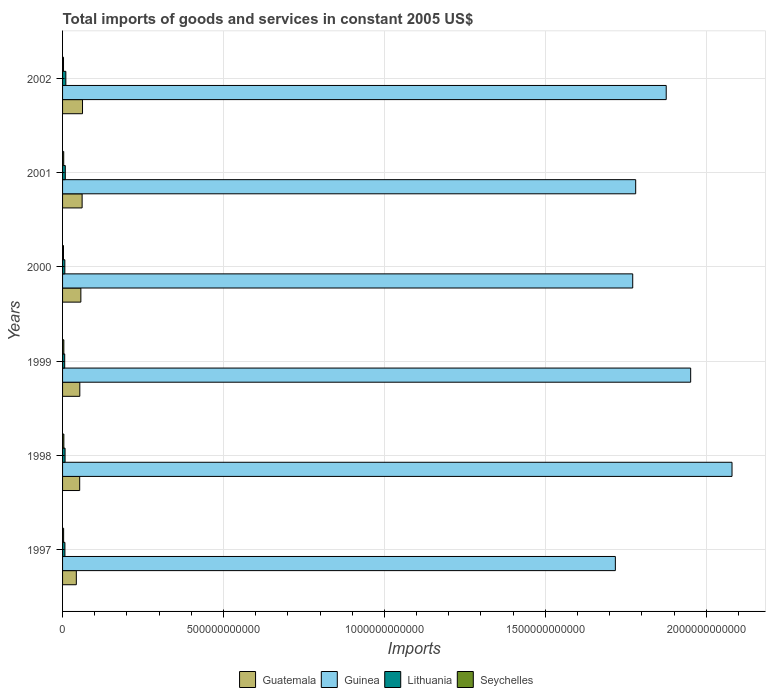How many different coloured bars are there?
Provide a succinct answer. 4. Are the number of bars on each tick of the Y-axis equal?
Ensure brevity in your answer.  Yes. How many bars are there on the 4th tick from the top?
Your answer should be very brief. 4. In how many cases, is the number of bars for a given year not equal to the number of legend labels?
Provide a succinct answer. 0. What is the total imports of goods and services in Guatemala in 2000?
Provide a short and direct response. 5.68e+1. Across all years, what is the maximum total imports of goods and services in Seychelles?
Your answer should be compact. 4.04e+09. Across all years, what is the minimum total imports of goods and services in Seychelles?
Your response must be concise. 2.89e+09. What is the total total imports of goods and services in Guinea in the graph?
Keep it short and to the point. 1.12e+13. What is the difference between the total imports of goods and services in Seychelles in 1998 and that in 2001?
Your response must be concise. 4.43e+08. What is the difference between the total imports of goods and services in Seychelles in 1998 and the total imports of goods and services in Guinea in 1999?
Ensure brevity in your answer.  -1.95e+12. What is the average total imports of goods and services in Lithuania per year?
Offer a terse response. 7.92e+09. In the year 1997, what is the difference between the total imports of goods and services in Guatemala and total imports of goods and services in Lithuania?
Ensure brevity in your answer.  3.54e+1. What is the ratio of the total imports of goods and services in Guinea in 1999 to that in 2000?
Your answer should be compact. 1.1. What is the difference between the highest and the second highest total imports of goods and services in Guatemala?
Provide a short and direct response. 1.21e+09. What is the difference between the highest and the lowest total imports of goods and services in Lithuania?
Your response must be concise. 3.54e+09. Is it the case that in every year, the sum of the total imports of goods and services in Guatemala and total imports of goods and services in Seychelles is greater than the sum of total imports of goods and services in Lithuania and total imports of goods and services in Guinea?
Provide a succinct answer. Yes. What does the 2nd bar from the top in 2000 represents?
Your answer should be very brief. Lithuania. What does the 4th bar from the bottom in 2000 represents?
Your answer should be compact. Seychelles. Is it the case that in every year, the sum of the total imports of goods and services in Seychelles and total imports of goods and services in Guinea is greater than the total imports of goods and services in Guatemala?
Your answer should be compact. Yes. What is the difference between two consecutive major ticks on the X-axis?
Your response must be concise. 5.00e+11. Does the graph contain any zero values?
Offer a terse response. No. Does the graph contain grids?
Give a very brief answer. Yes. Where does the legend appear in the graph?
Give a very brief answer. Bottom center. How are the legend labels stacked?
Make the answer very short. Horizontal. What is the title of the graph?
Keep it short and to the point. Total imports of goods and services in constant 2005 US$. What is the label or title of the X-axis?
Make the answer very short. Imports. What is the Imports in Guatemala in 1997?
Ensure brevity in your answer.  4.27e+1. What is the Imports of Guinea in 1997?
Offer a terse response. 1.72e+12. What is the Imports in Lithuania in 1997?
Your response must be concise. 7.31e+09. What is the Imports in Seychelles in 1997?
Make the answer very short. 3.27e+09. What is the Imports in Guatemala in 1998?
Offer a terse response. 5.32e+1. What is the Imports of Guinea in 1998?
Ensure brevity in your answer.  2.08e+12. What is the Imports in Lithuania in 1998?
Your answer should be compact. 7.78e+09. What is the Imports of Seychelles in 1998?
Keep it short and to the point. 4.04e+09. What is the Imports in Guatemala in 1999?
Offer a terse response. 5.36e+1. What is the Imports in Guinea in 1999?
Provide a succinct answer. 1.95e+12. What is the Imports of Lithuania in 1999?
Ensure brevity in your answer.  6.65e+09. What is the Imports of Seychelles in 1999?
Your answer should be very brief. 3.99e+09. What is the Imports in Guatemala in 2000?
Offer a terse response. 5.68e+1. What is the Imports in Guinea in 2000?
Provide a succinct answer. 1.77e+12. What is the Imports in Lithuania in 2000?
Make the answer very short. 7.09e+09. What is the Imports of Seychelles in 2000?
Keep it short and to the point. 2.89e+09. What is the Imports of Guatemala in 2001?
Your answer should be compact. 6.08e+1. What is the Imports of Guinea in 2001?
Offer a terse response. 1.78e+12. What is the Imports of Lithuania in 2001?
Your answer should be very brief. 8.48e+09. What is the Imports in Seychelles in 2001?
Offer a terse response. 3.60e+09. What is the Imports of Guatemala in 2002?
Your answer should be compact. 6.20e+1. What is the Imports of Guinea in 2002?
Ensure brevity in your answer.  1.88e+12. What is the Imports of Lithuania in 2002?
Make the answer very short. 1.02e+1. What is the Imports of Seychelles in 2002?
Your answer should be very brief. 2.96e+09. Across all years, what is the maximum Imports of Guatemala?
Offer a terse response. 6.20e+1. Across all years, what is the maximum Imports of Guinea?
Ensure brevity in your answer.  2.08e+12. Across all years, what is the maximum Imports in Lithuania?
Keep it short and to the point. 1.02e+1. Across all years, what is the maximum Imports of Seychelles?
Your answer should be very brief. 4.04e+09. Across all years, what is the minimum Imports of Guatemala?
Give a very brief answer. 4.27e+1. Across all years, what is the minimum Imports of Guinea?
Offer a very short reply. 1.72e+12. Across all years, what is the minimum Imports of Lithuania?
Give a very brief answer. 6.65e+09. Across all years, what is the minimum Imports in Seychelles?
Your response must be concise. 2.89e+09. What is the total Imports of Guatemala in the graph?
Give a very brief answer. 3.29e+11. What is the total Imports of Guinea in the graph?
Offer a terse response. 1.12e+13. What is the total Imports in Lithuania in the graph?
Ensure brevity in your answer.  4.75e+1. What is the total Imports of Seychelles in the graph?
Ensure brevity in your answer.  2.07e+1. What is the difference between the Imports in Guatemala in 1997 and that in 1998?
Offer a very short reply. -1.05e+1. What is the difference between the Imports of Guinea in 1997 and that in 1998?
Provide a short and direct response. -3.62e+11. What is the difference between the Imports in Lithuania in 1997 and that in 1998?
Keep it short and to the point. -4.70e+08. What is the difference between the Imports in Seychelles in 1997 and that in 1998?
Make the answer very short. -7.69e+08. What is the difference between the Imports in Guatemala in 1997 and that in 1999?
Offer a terse response. -1.09e+1. What is the difference between the Imports in Guinea in 1997 and that in 1999?
Give a very brief answer. -2.34e+11. What is the difference between the Imports of Lithuania in 1997 and that in 1999?
Provide a short and direct response. 6.62e+08. What is the difference between the Imports of Seychelles in 1997 and that in 1999?
Provide a succinct answer. -7.12e+08. What is the difference between the Imports in Guatemala in 1997 and that in 2000?
Your answer should be very brief. -1.41e+1. What is the difference between the Imports in Guinea in 1997 and that in 2000?
Give a very brief answer. -5.39e+1. What is the difference between the Imports in Lithuania in 1997 and that in 2000?
Provide a short and direct response. 2.23e+08. What is the difference between the Imports in Seychelles in 1997 and that in 2000?
Keep it short and to the point. 3.85e+08. What is the difference between the Imports of Guatemala in 1997 and that in 2001?
Provide a succinct answer. -1.80e+1. What is the difference between the Imports of Guinea in 1997 and that in 2001?
Your response must be concise. -6.32e+1. What is the difference between the Imports in Lithuania in 1997 and that in 2001?
Your response must be concise. -1.17e+09. What is the difference between the Imports in Seychelles in 1997 and that in 2001?
Offer a terse response. -3.26e+08. What is the difference between the Imports in Guatemala in 1997 and that in 2002?
Offer a very short reply. -1.92e+1. What is the difference between the Imports in Guinea in 1997 and that in 2002?
Provide a short and direct response. -1.58e+11. What is the difference between the Imports of Lithuania in 1997 and that in 2002?
Offer a terse response. -2.88e+09. What is the difference between the Imports in Seychelles in 1997 and that in 2002?
Provide a succinct answer. 3.17e+08. What is the difference between the Imports in Guatemala in 1998 and that in 1999?
Offer a very short reply. -3.79e+08. What is the difference between the Imports of Guinea in 1998 and that in 1999?
Offer a very short reply. 1.28e+11. What is the difference between the Imports of Lithuania in 1998 and that in 1999?
Ensure brevity in your answer.  1.13e+09. What is the difference between the Imports of Seychelles in 1998 and that in 1999?
Provide a short and direct response. 5.78e+07. What is the difference between the Imports of Guatemala in 1998 and that in 2000?
Make the answer very short. -3.61e+09. What is the difference between the Imports in Guinea in 1998 and that in 2000?
Offer a very short reply. 3.08e+11. What is the difference between the Imports of Lithuania in 1998 and that in 2000?
Give a very brief answer. 6.93e+08. What is the difference between the Imports in Seychelles in 1998 and that in 2000?
Provide a short and direct response. 1.15e+09. What is the difference between the Imports in Guatemala in 1998 and that in 2001?
Offer a terse response. -7.55e+09. What is the difference between the Imports of Guinea in 1998 and that in 2001?
Offer a terse response. 2.99e+11. What is the difference between the Imports of Lithuania in 1998 and that in 2001?
Offer a very short reply. -7.04e+08. What is the difference between the Imports of Seychelles in 1998 and that in 2001?
Your answer should be compact. 4.43e+08. What is the difference between the Imports of Guatemala in 1998 and that in 2002?
Provide a succinct answer. -8.75e+09. What is the difference between the Imports in Guinea in 1998 and that in 2002?
Keep it short and to the point. 2.04e+11. What is the difference between the Imports of Lithuania in 1998 and that in 2002?
Make the answer very short. -2.41e+09. What is the difference between the Imports in Seychelles in 1998 and that in 2002?
Your response must be concise. 1.09e+09. What is the difference between the Imports in Guatemala in 1999 and that in 2000?
Your response must be concise. -3.23e+09. What is the difference between the Imports in Guinea in 1999 and that in 2000?
Offer a terse response. 1.80e+11. What is the difference between the Imports of Lithuania in 1999 and that in 2000?
Provide a succinct answer. -4.38e+08. What is the difference between the Imports in Seychelles in 1999 and that in 2000?
Provide a short and direct response. 1.10e+09. What is the difference between the Imports in Guatemala in 1999 and that in 2001?
Make the answer very short. -7.17e+09. What is the difference between the Imports of Guinea in 1999 and that in 2001?
Keep it short and to the point. 1.71e+11. What is the difference between the Imports in Lithuania in 1999 and that in 2001?
Provide a short and direct response. -1.84e+09. What is the difference between the Imports in Seychelles in 1999 and that in 2001?
Provide a short and direct response. 3.86e+08. What is the difference between the Imports in Guatemala in 1999 and that in 2002?
Your answer should be very brief. -8.37e+09. What is the difference between the Imports of Guinea in 1999 and that in 2002?
Provide a short and direct response. 7.60e+1. What is the difference between the Imports in Lithuania in 1999 and that in 2002?
Give a very brief answer. -3.54e+09. What is the difference between the Imports in Seychelles in 1999 and that in 2002?
Your answer should be very brief. 1.03e+09. What is the difference between the Imports in Guatemala in 2000 and that in 2001?
Provide a succinct answer. -3.93e+09. What is the difference between the Imports in Guinea in 2000 and that in 2001?
Ensure brevity in your answer.  -9.21e+09. What is the difference between the Imports in Lithuania in 2000 and that in 2001?
Your answer should be compact. -1.40e+09. What is the difference between the Imports in Seychelles in 2000 and that in 2001?
Give a very brief answer. -7.12e+08. What is the difference between the Imports in Guatemala in 2000 and that in 2002?
Provide a succinct answer. -5.14e+09. What is the difference between the Imports in Guinea in 2000 and that in 2002?
Your answer should be very brief. -1.04e+11. What is the difference between the Imports of Lithuania in 2000 and that in 2002?
Keep it short and to the point. -3.10e+09. What is the difference between the Imports in Seychelles in 2000 and that in 2002?
Your response must be concise. -6.88e+07. What is the difference between the Imports of Guatemala in 2001 and that in 2002?
Offer a very short reply. -1.21e+09. What is the difference between the Imports in Guinea in 2001 and that in 2002?
Give a very brief answer. -9.49e+1. What is the difference between the Imports in Lithuania in 2001 and that in 2002?
Give a very brief answer. -1.71e+09. What is the difference between the Imports in Seychelles in 2001 and that in 2002?
Your answer should be compact. 6.43e+08. What is the difference between the Imports of Guatemala in 1997 and the Imports of Guinea in 1998?
Your answer should be compact. -2.04e+12. What is the difference between the Imports in Guatemala in 1997 and the Imports in Lithuania in 1998?
Keep it short and to the point. 3.50e+1. What is the difference between the Imports in Guatemala in 1997 and the Imports in Seychelles in 1998?
Your response must be concise. 3.87e+1. What is the difference between the Imports in Guinea in 1997 and the Imports in Lithuania in 1998?
Keep it short and to the point. 1.71e+12. What is the difference between the Imports of Guinea in 1997 and the Imports of Seychelles in 1998?
Your answer should be very brief. 1.71e+12. What is the difference between the Imports of Lithuania in 1997 and the Imports of Seychelles in 1998?
Offer a terse response. 3.27e+09. What is the difference between the Imports in Guatemala in 1997 and the Imports in Guinea in 1999?
Give a very brief answer. -1.91e+12. What is the difference between the Imports in Guatemala in 1997 and the Imports in Lithuania in 1999?
Make the answer very short. 3.61e+1. What is the difference between the Imports in Guatemala in 1997 and the Imports in Seychelles in 1999?
Give a very brief answer. 3.88e+1. What is the difference between the Imports of Guinea in 1997 and the Imports of Lithuania in 1999?
Provide a succinct answer. 1.71e+12. What is the difference between the Imports of Guinea in 1997 and the Imports of Seychelles in 1999?
Provide a succinct answer. 1.71e+12. What is the difference between the Imports in Lithuania in 1997 and the Imports in Seychelles in 1999?
Make the answer very short. 3.32e+09. What is the difference between the Imports of Guatemala in 1997 and the Imports of Guinea in 2000?
Your answer should be very brief. -1.73e+12. What is the difference between the Imports in Guatemala in 1997 and the Imports in Lithuania in 2000?
Your answer should be very brief. 3.57e+1. What is the difference between the Imports of Guatemala in 1997 and the Imports of Seychelles in 2000?
Provide a short and direct response. 3.99e+1. What is the difference between the Imports in Guinea in 1997 and the Imports in Lithuania in 2000?
Provide a succinct answer. 1.71e+12. What is the difference between the Imports of Guinea in 1997 and the Imports of Seychelles in 2000?
Make the answer very short. 1.71e+12. What is the difference between the Imports of Lithuania in 1997 and the Imports of Seychelles in 2000?
Offer a very short reply. 4.42e+09. What is the difference between the Imports of Guatemala in 1997 and the Imports of Guinea in 2001?
Your answer should be compact. -1.74e+12. What is the difference between the Imports in Guatemala in 1997 and the Imports in Lithuania in 2001?
Keep it short and to the point. 3.43e+1. What is the difference between the Imports of Guatemala in 1997 and the Imports of Seychelles in 2001?
Provide a succinct answer. 3.91e+1. What is the difference between the Imports of Guinea in 1997 and the Imports of Lithuania in 2001?
Your answer should be compact. 1.71e+12. What is the difference between the Imports of Guinea in 1997 and the Imports of Seychelles in 2001?
Your answer should be very brief. 1.71e+12. What is the difference between the Imports in Lithuania in 1997 and the Imports in Seychelles in 2001?
Ensure brevity in your answer.  3.71e+09. What is the difference between the Imports of Guatemala in 1997 and the Imports of Guinea in 2002?
Your answer should be compact. -1.83e+12. What is the difference between the Imports in Guatemala in 1997 and the Imports in Lithuania in 2002?
Provide a succinct answer. 3.25e+1. What is the difference between the Imports in Guatemala in 1997 and the Imports in Seychelles in 2002?
Provide a short and direct response. 3.98e+1. What is the difference between the Imports of Guinea in 1997 and the Imports of Lithuania in 2002?
Give a very brief answer. 1.71e+12. What is the difference between the Imports of Guinea in 1997 and the Imports of Seychelles in 2002?
Your response must be concise. 1.71e+12. What is the difference between the Imports of Lithuania in 1997 and the Imports of Seychelles in 2002?
Offer a very short reply. 4.35e+09. What is the difference between the Imports in Guatemala in 1998 and the Imports in Guinea in 1999?
Offer a terse response. -1.90e+12. What is the difference between the Imports in Guatemala in 1998 and the Imports in Lithuania in 1999?
Provide a succinct answer. 4.66e+1. What is the difference between the Imports in Guatemala in 1998 and the Imports in Seychelles in 1999?
Make the answer very short. 4.92e+1. What is the difference between the Imports of Guinea in 1998 and the Imports of Lithuania in 1999?
Keep it short and to the point. 2.07e+12. What is the difference between the Imports of Guinea in 1998 and the Imports of Seychelles in 1999?
Your answer should be compact. 2.08e+12. What is the difference between the Imports of Lithuania in 1998 and the Imports of Seychelles in 1999?
Offer a terse response. 3.79e+09. What is the difference between the Imports in Guatemala in 1998 and the Imports in Guinea in 2000?
Provide a succinct answer. -1.72e+12. What is the difference between the Imports of Guatemala in 1998 and the Imports of Lithuania in 2000?
Your answer should be compact. 4.61e+1. What is the difference between the Imports in Guatemala in 1998 and the Imports in Seychelles in 2000?
Your response must be concise. 5.03e+1. What is the difference between the Imports of Guinea in 1998 and the Imports of Lithuania in 2000?
Make the answer very short. 2.07e+12. What is the difference between the Imports in Guinea in 1998 and the Imports in Seychelles in 2000?
Ensure brevity in your answer.  2.08e+12. What is the difference between the Imports of Lithuania in 1998 and the Imports of Seychelles in 2000?
Provide a short and direct response. 4.89e+09. What is the difference between the Imports in Guatemala in 1998 and the Imports in Guinea in 2001?
Make the answer very short. -1.73e+12. What is the difference between the Imports in Guatemala in 1998 and the Imports in Lithuania in 2001?
Your answer should be compact. 4.47e+1. What is the difference between the Imports of Guatemala in 1998 and the Imports of Seychelles in 2001?
Keep it short and to the point. 4.96e+1. What is the difference between the Imports in Guinea in 1998 and the Imports in Lithuania in 2001?
Provide a short and direct response. 2.07e+12. What is the difference between the Imports in Guinea in 1998 and the Imports in Seychelles in 2001?
Your answer should be very brief. 2.08e+12. What is the difference between the Imports in Lithuania in 1998 and the Imports in Seychelles in 2001?
Make the answer very short. 4.18e+09. What is the difference between the Imports in Guatemala in 1998 and the Imports in Guinea in 2002?
Provide a short and direct response. -1.82e+12. What is the difference between the Imports in Guatemala in 1998 and the Imports in Lithuania in 2002?
Your response must be concise. 4.30e+1. What is the difference between the Imports in Guatemala in 1998 and the Imports in Seychelles in 2002?
Offer a terse response. 5.03e+1. What is the difference between the Imports in Guinea in 1998 and the Imports in Lithuania in 2002?
Offer a very short reply. 2.07e+12. What is the difference between the Imports in Guinea in 1998 and the Imports in Seychelles in 2002?
Your answer should be very brief. 2.08e+12. What is the difference between the Imports of Lithuania in 1998 and the Imports of Seychelles in 2002?
Provide a succinct answer. 4.82e+09. What is the difference between the Imports of Guatemala in 1999 and the Imports of Guinea in 2000?
Keep it short and to the point. -1.72e+12. What is the difference between the Imports in Guatemala in 1999 and the Imports in Lithuania in 2000?
Offer a terse response. 4.65e+1. What is the difference between the Imports of Guatemala in 1999 and the Imports of Seychelles in 2000?
Give a very brief answer. 5.07e+1. What is the difference between the Imports in Guinea in 1999 and the Imports in Lithuania in 2000?
Give a very brief answer. 1.94e+12. What is the difference between the Imports in Guinea in 1999 and the Imports in Seychelles in 2000?
Your answer should be compact. 1.95e+12. What is the difference between the Imports of Lithuania in 1999 and the Imports of Seychelles in 2000?
Provide a succinct answer. 3.76e+09. What is the difference between the Imports in Guatemala in 1999 and the Imports in Guinea in 2001?
Keep it short and to the point. -1.73e+12. What is the difference between the Imports of Guatemala in 1999 and the Imports of Lithuania in 2001?
Keep it short and to the point. 4.51e+1. What is the difference between the Imports of Guatemala in 1999 and the Imports of Seychelles in 2001?
Your answer should be compact. 5.00e+1. What is the difference between the Imports in Guinea in 1999 and the Imports in Lithuania in 2001?
Give a very brief answer. 1.94e+12. What is the difference between the Imports in Guinea in 1999 and the Imports in Seychelles in 2001?
Offer a terse response. 1.95e+12. What is the difference between the Imports in Lithuania in 1999 and the Imports in Seychelles in 2001?
Your answer should be compact. 3.05e+09. What is the difference between the Imports in Guatemala in 1999 and the Imports in Guinea in 2002?
Ensure brevity in your answer.  -1.82e+12. What is the difference between the Imports of Guatemala in 1999 and the Imports of Lithuania in 2002?
Your answer should be compact. 4.34e+1. What is the difference between the Imports in Guatemala in 1999 and the Imports in Seychelles in 2002?
Your answer should be very brief. 5.06e+1. What is the difference between the Imports in Guinea in 1999 and the Imports in Lithuania in 2002?
Offer a terse response. 1.94e+12. What is the difference between the Imports of Guinea in 1999 and the Imports of Seychelles in 2002?
Ensure brevity in your answer.  1.95e+12. What is the difference between the Imports of Lithuania in 1999 and the Imports of Seychelles in 2002?
Make the answer very short. 3.69e+09. What is the difference between the Imports of Guatemala in 2000 and the Imports of Guinea in 2001?
Give a very brief answer. -1.72e+12. What is the difference between the Imports of Guatemala in 2000 and the Imports of Lithuania in 2001?
Your answer should be compact. 4.83e+1. What is the difference between the Imports of Guatemala in 2000 and the Imports of Seychelles in 2001?
Give a very brief answer. 5.32e+1. What is the difference between the Imports of Guinea in 2000 and the Imports of Lithuania in 2001?
Ensure brevity in your answer.  1.76e+12. What is the difference between the Imports in Guinea in 2000 and the Imports in Seychelles in 2001?
Your response must be concise. 1.77e+12. What is the difference between the Imports in Lithuania in 2000 and the Imports in Seychelles in 2001?
Keep it short and to the point. 3.49e+09. What is the difference between the Imports in Guatemala in 2000 and the Imports in Guinea in 2002?
Provide a succinct answer. -1.82e+12. What is the difference between the Imports in Guatemala in 2000 and the Imports in Lithuania in 2002?
Give a very brief answer. 4.66e+1. What is the difference between the Imports of Guatemala in 2000 and the Imports of Seychelles in 2002?
Keep it short and to the point. 5.39e+1. What is the difference between the Imports of Guinea in 2000 and the Imports of Lithuania in 2002?
Provide a succinct answer. 1.76e+12. What is the difference between the Imports in Guinea in 2000 and the Imports in Seychelles in 2002?
Offer a very short reply. 1.77e+12. What is the difference between the Imports in Lithuania in 2000 and the Imports in Seychelles in 2002?
Keep it short and to the point. 4.13e+09. What is the difference between the Imports in Guatemala in 2001 and the Imports in Guinea in 2002?
Ensure brevity in your answer.  -1.81e+12. What is the difference between the Imports of Guatemala in 2001 and the Imports of Lithuania in 2002?
Your answer should be compact. 5.06e+1. What is the difference between the Imports in Guatemala in 2001 and the Imports in Seychelles in 2002?
Ensure brevity in your answer.  5.78e+1. What is the difference between the Imports of Guinea in 2001 and the Imports of Lithuania in 2002?
Your response must be concise. 1.77e+12. What is the difference between the Imports of Guinea in 2001 and the Imports of Seychelles in 2002?
Ensure brevity in your answer.  1.78e+12. What is the difference between the Imports of Lithuania in 2001 and the Imports of Seychelles in 2002?
Keep it short and to the point. 5.53e+09. What is the average Imports in Guatemala per year?
Ensure brevity in your answer.  5.48e+1. What is the average Imports in Guinea per year?
Offer a terse response. 1.86e+12. What is the average Imports in Lithuania per year?
Keep it short and to the point. 7.92e+09. What is the average Imports in Seychelles per year?
Provide a succinct answer. 3.46e+09. In the year 1997, what is the difference between the Imports in Guatemala and Imports in Guinea?
Keep it short and to the point. -1.67e+12. In the year 1997, what is the difference between the Imports of Guatemala and Imports of Lithuania?
Make the answer very short. 3.54e+1. In the year 1997, what is the difference between the Imports of Guatemala and Imports of Seychelles?
Make the answer very short. 3.95e+1. In the year 1997, what is the difference between the Imports in Guinea and Imports in Lithuania?
Ensure brevity in your answer.  1.71e+12. In the year 1997, what is the difference between the Imports in Guinea and Imports in Seychelles?
Make the answer very short. 1.71e+12. In the year 1997, what is the difference between the Imports in Lithuania and Imports in Seychelles?
Ensure brevity in your answer.  4.04e+09. In the year 1998, what is the difference between the Imports of Guatemala and Imports of Guinea?
Make the answer very short. -2.03e+12. In the year 1998, what is the difference between the Imports of Guatemala and Imports of Lithuania?
Offer a very short reply. 4.54e+1. In the year 1998, what is the difference between the Imports in Guatemala and Imports in Seychelles?
Offer a terse response. 4.92e+1. In the year 1998, what is the difference between the Imports in Guinea and Imports in Lithuania?
Give a very brief answer. 2.07e+12. In the year 1998, what is the difference between the Imports in Guinea and Imports in Seychelles?
Your answer should be very brief. 2.08e+12. In the year 1998, what is the difference between the Imports of Lithuania and Imports of Seychelles?
Provide a succinct answer. 3.74e+09. In the year 1999, what is the difference between the Imports in Guatemala and Imports in Guinea?
Make the answer very short. -1.90e+12. In the year 1999, what is the difference between the Imports of Guatemala and Imports of Lithuania?
Make the answer very short. 4.69e+1. In the year 1999, what is the difference between the Imports in Guatemala and Imports in Seychelles?
Keep it short and to the point. 4.96e+1. In the year 1999, what is the difference between the Imports in Guinea and Imports in Lithuania?
Offer a terse response. 1.94e+12. In the year 1999, what is the difference between the Imports of Guinea and Imports of Seychelles?
Your answer should be compact. 1.95e+12. In the year 1999, what is the difference between the Imports of Lithuania and Imports of Seychelles?
Your answer should be compact. 2.66e+09. In the year 2000, what is the difference between the Imports of Guatemala and Imports of Guinea?
Make the answer very short. -1.71e+12. In the year 2000, what is the difference between the Imports of Guatemala and Imports of Lithuania?
Offer a very short reply. 4.97e+1. In the year 2000, what is the difference between the Imports in Guatemala and Imports in Seychelles?
Provide a short and direct response. 5.39e+1. In the year 2000, what is the difference between the Imports of Guinea and Imports of Lithuania?
Provide a succinct answer. 1.76e+12. In the year 2000, what is the difference between the Imports of Guinea and Imports of Seychelles?
Make the answer very short. 1.77e+12. In the year 2000, what is the difference between the Imports in Lithuania and Imports in Seychelles?
Offer a terse response. 4.20e+09. In the year 2001, what is the difference between the Imports in Guatemala and Imports in Guinea?
Offer a terse response. -1.72e+12. In the year 2001, what is the difference between the Imports of Guatemala and Imports of Lithuania?
Your answer should be very brief. 5.23e+1. In the year 2001, what is the difference between the Imports of Guatemala and Imports of Seychelles?
Your answer should be compact. 5.72e+1. In the year 2001, what is the difference between the Imports in Guinea and Imports in Lithuania?
Provide a succinct answer. 1.77e+12. In the year 2001, what is the difference between the Imports of Guinea and Imports of Seychelles?
Offer a terse response. 1.78e+12. In the year 2001, what is the difference between the Imports of Lithuania and Imports of Seychelles?
Your response must be concise. 4.88e+09. In the year 2002, what is the difference between the Imports of Guatemala and Imports of Guinea?
Your answer should be compact. -1.81e+12. In the year 2002, what is the difference between the Imports of Guatemala and Imports of Lithuania?
Your response must be concise. 5.18e+1. In the year 2002, what is the difference between the Imports in Guatemala and Imports in Seychelles?
Keep it short and to the point. 5.90e+1. In the year 2002, what is the difference between the Imports in Guinea and Imports in Lithuania?
Offer a terse response. 1.87e+12. In the year 2002, what is the difference between the Imports in Guinea and Imports in Seychelles?
Make the answer very short. 1.87e+12. In the year 2002, what is the difference between the Imports of Lithuania and Imports of Seychelles?
Keep it short and to the point. 7.23e+09. What is the ratio of the Imports of Guatemala in 1997 to that in 1998?
Keep it short and to the point. 0.8. What is the ratio of the Imports of Guinea in 1997 to that in 1998?
Offer a very short reply. 0.83. What is the ratio of the Imports of Lithuania in 1997 to that in 1998?
Provide a succinct answer. 0.94. What is the ratio of the Imports of Seychelles in 1997 to that in 1998?
Your response must be concise. 0.81. What is the ratio of the Imports in Guatemala in 1997 to that in 1999?
Give a very brief answer. 0.8. What is the ratio of the Imports of Guinea in 1997 to that in 1999?
Your response must be concise. 0.88. What is the ratio of the Imports in Lithuania in 1997 to that in 1999?
Provide a short and direct response. 1.1. What is the ratio of the Imports in Seychelles in 1997 to that in 1999?
Provide a succinct answer. 0.82. What is the ratio of the Imports in Guatemala in 1997 to that in 2000?
Give a very brief answer. 0.75. What is the ratio of the Imports in Guinea in 1997 to that in 2000?
Provide a short and direct response. 0.97. What is the ratio of the Imports in Lithuania in 1997 to that in 2000?
Your answer should be compact. 1.03. What is the ratio of the Imports of Seychelles in 1997 to that in 2000?
Offer a very short reply. 1.13. What is the ratio of the Imports in Guatemala in 1997 to that in 2001?
Provide a succinct answer. 0.7. What is the ratio of the Imports of Guinea in 1997 to that in 2001?
Your answer should be compact. 0.96. What is the ratio of the Imports in Lithuania in 1997 to that in 2001?
Your answer should be compact. 0.86. What is the ratio of the Imports of Seychelles in 1997 to that in 2001?
Make the answer very short. 0.91. What is the ratio of the Imports in Guatemala in 1997 to that in 2002?
Make the answer very short. 0.69. What is the ratio of the Imports of Guinea in 1997 to that in 2002?
Offer a terse response. 0.92. What is the ratio of the Imports in Lithuania in 1997 to that in 2002?
Keep it short and to the point. 0.72. What is the ratio of the Imports of Seychelles in 1997 to that in 2002?
Your response must be concise. 1.11. What is the ratio of the Imports of Guatemala in 1998 to that in 1999?
Your answer should be compact. 0.99. What is the ratio of the Imports in Guinea in 1998 to that in 1999?
Provide a short and direct response. 1.07. What is the ratio of the Imports in Lithuania in 1998 to that in 1999?
Keep it short and to the point. 1.17. What is the ratio of the Imports of Seychelles in 1998 to that in 1999?
Ensure brevity in your answer.  1.01. What is the ratio of the Imports of Guatemala in 1998 to that in 2000?
Keep it short and to the point. 0.94. What is the ratio of the Imports in Guinea in 1998 to that in 2000?
Make the answer very short. 1.17. What is the ratio of the Imports of Lithuania in 1998 to that in 2000?
Offer a terse response. 1.1. What is the ratio of the Imports in Seychelles in 1998 to that in 2000?
Your answer should be very brief. 1.4. What is the ratio of the Imports of Guatemala in 1998 to that in 2001?
Ensure brevity in your answer.  0.88. What is the ratio of the Imports in Guinea in 1998 to that in 2001?
Your response must be concise. 1.17. What is the ratio of the Imports in Lithuania in 1998 to that in 2001?
Ensure brevity in your answer.  0.92. What is the ratio of the Imports in Seychelles in 1998 to that in 2001?
Your answer should be very brief. 1.12. What is the ratio of the Imports of Guatemala in 1998 to that in 2002?
Provide a short and direct response. 0.86. What is the ratio of the Imports of Guinea in 1998 to that in 2002?
Make the answer very short. 1.11. What is the ratio of the Imports of Lithuania in 1998 to that in 2002?
Your answer should be compact. 0.76. What is the ratio of the Imports in Seychelles in 1998 to that in 2002?
Provide a succinct answer. 1.37. What is the ratio of the Imports in Guatemala in 1999 to that in 2000?
Your answer should be very brief. 0.94. What is the ratio of the Imports in Guinea in 1999 to that in 2000?
Provide a succinct answer. 1.1. What is the ratio of the Imports of Lithuania in 1999 to that in 2000?
Keep it short and to the point. 0.94. What is the ratio of the Imports in Seychelles in 1999 to that in 2000?
Provide a short and direct response. 1.38. What is the ratio of the Imports of Guatemala in 1999 to that in 2001?
Make the answer very short. 0.88. What is the ratio of the Imports of Guinea in 1999 to that in 2001?
Offer a very short reply. 1.1. What is the ratio of the Imports in Lithuania in 1999 to that in 2001?
Ensure brevity in your answer.  0.78. What is the ratio of the Imports of Seychelles in 1999 to that in 2001?
Keep it short and to the point. 1.11. What is the ratio of the Imports of Guatemala in 1999 to that in 2002?
Provide a succinct answer. 0.86. What is the ratio of the Imports of Guinea in 1999 to that in 2002?
Make the answer very short. 1.04. What is the ratio of the Imports of Lithuania in 1999 to that in 2002?
Your response must be concise. 0.65. What is the ratio of the Imports of Seychelles in 1999 to that in 2002?
Offer a terse response. 1.35. What is the ratio of the Imports of Guatemala in 2000 to that in 2001?
Ensure brevity in your answer.  0.94. What is the ratio of the Imports of Guinea in 2000 to that in 2001?
Provide a succinct answer. 0.99. What is the ratio of the Imports in Lithuania in 2000 to that in 2001?
Ensure brevity in your answer.  0.84. What is the ratio of the Imports in Seychelles in 2000 to that in 2001?
Offer a terse response. 0.8. What is the ratio of the Imports in Guatemala in 2000 to that in 2002?
Make the answer very short. 0.92. What is the ratio of the Imports in Guinea in 2000 to that in 2002?
Make the answer very short. 0.94. What is the ratio of the Imports in Lithuania in 2000 to that in 2002?
Offer a very short reply. 0.7. What is the ratio of the Imports of Seychelles in 2000 to that in 2002?
Offer a very short reply. 0.98. What is the ratio of the Imports of Guatemala in 2001 to that in 2002?
Ensure brevity in your answer.  0.98. What is the ratio of the Imports in Guinea in 2001 to that in 2002?
Ensure brevity in your answer.  0.95. What is the ratio of the Imports in Lithuania in 2001 to that in 2002?
Keep it short and to the point. 0.83. What is the ratio of the Imports in Seychelles in 2001 to that in 2002?
Provide a succinct answer. 1.22. What is the difference between the highest and the second highest Imports in Guatemala?
Offer a very short reply. 1.21e+09. What is the difference between the highest and the second highest Imports of Guinea?
Offer a terse response. 1.28e+11. What is the difference between the highest and the second highest Imports in Lithuania?
Your answer should be very brief. 1.71e+09. What is the difference between the highest and the second highest Imports in Seychelles?
Your response must be concise. 5.78e+07. What is the difference between the highest and the lowest Imports in Guatemala?
Provide a succinct answer. 1.92e+1. What is the difference between the highest and the lowest Imports of Guinea?
Offer a very short reply. 3.62e+11. What is the difference between the highest and the lowest Imports of Lithuania?
Ensure brevity in your answer.  3.54e+09. What is the difference between the highest and the lowest Imports in Seychelles?
Provide a succinct answer. 1.15e+09. 